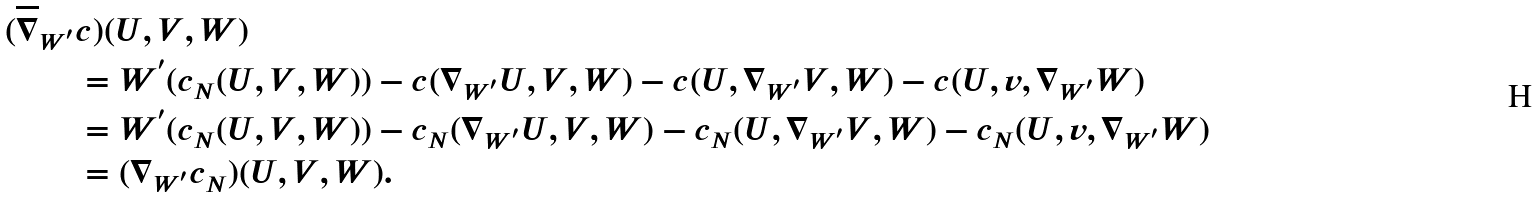Convert formula to latex. <formula><loc_0><loc_0><loc_500><loc_500>( \overline { \nabla } _ { W ^ { ^ { \prime } } } & c ) ( U , V , W ) \\ & = W ^ { ^ { \prime } } ( c _ { N } ( U , V , W ) ) - c ( \nabla _ { W ^ { ^ { \prime } } } U , V , W ) - c ( U , \nabla _ { W ^ { ^ { \prime } } } V , W ) - c ( U , v , \nabla _ { W ^ { ^ { \prime } } } W ) \\ & = W ^ { ^ { \prime } } ( c _ { N } ( U , V , W ) ) - c _ { N } ( \nabla _ { W ^ { ^ { \prime } } } U , V , W ) - c _ { N } ( U , \nabla _ { W ^ { ^ { \prime } } } V , W ) - c _ { N } ( U , v , \nabla _ { W ^ { ^ { \prime } } } W ) \\ & = ( \nabla _ { W ^ { ^ { \prime } } } c _ { N } ) ( U , V , W ) .</formula> 